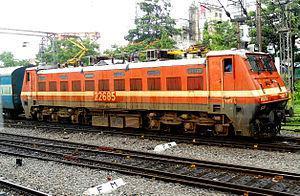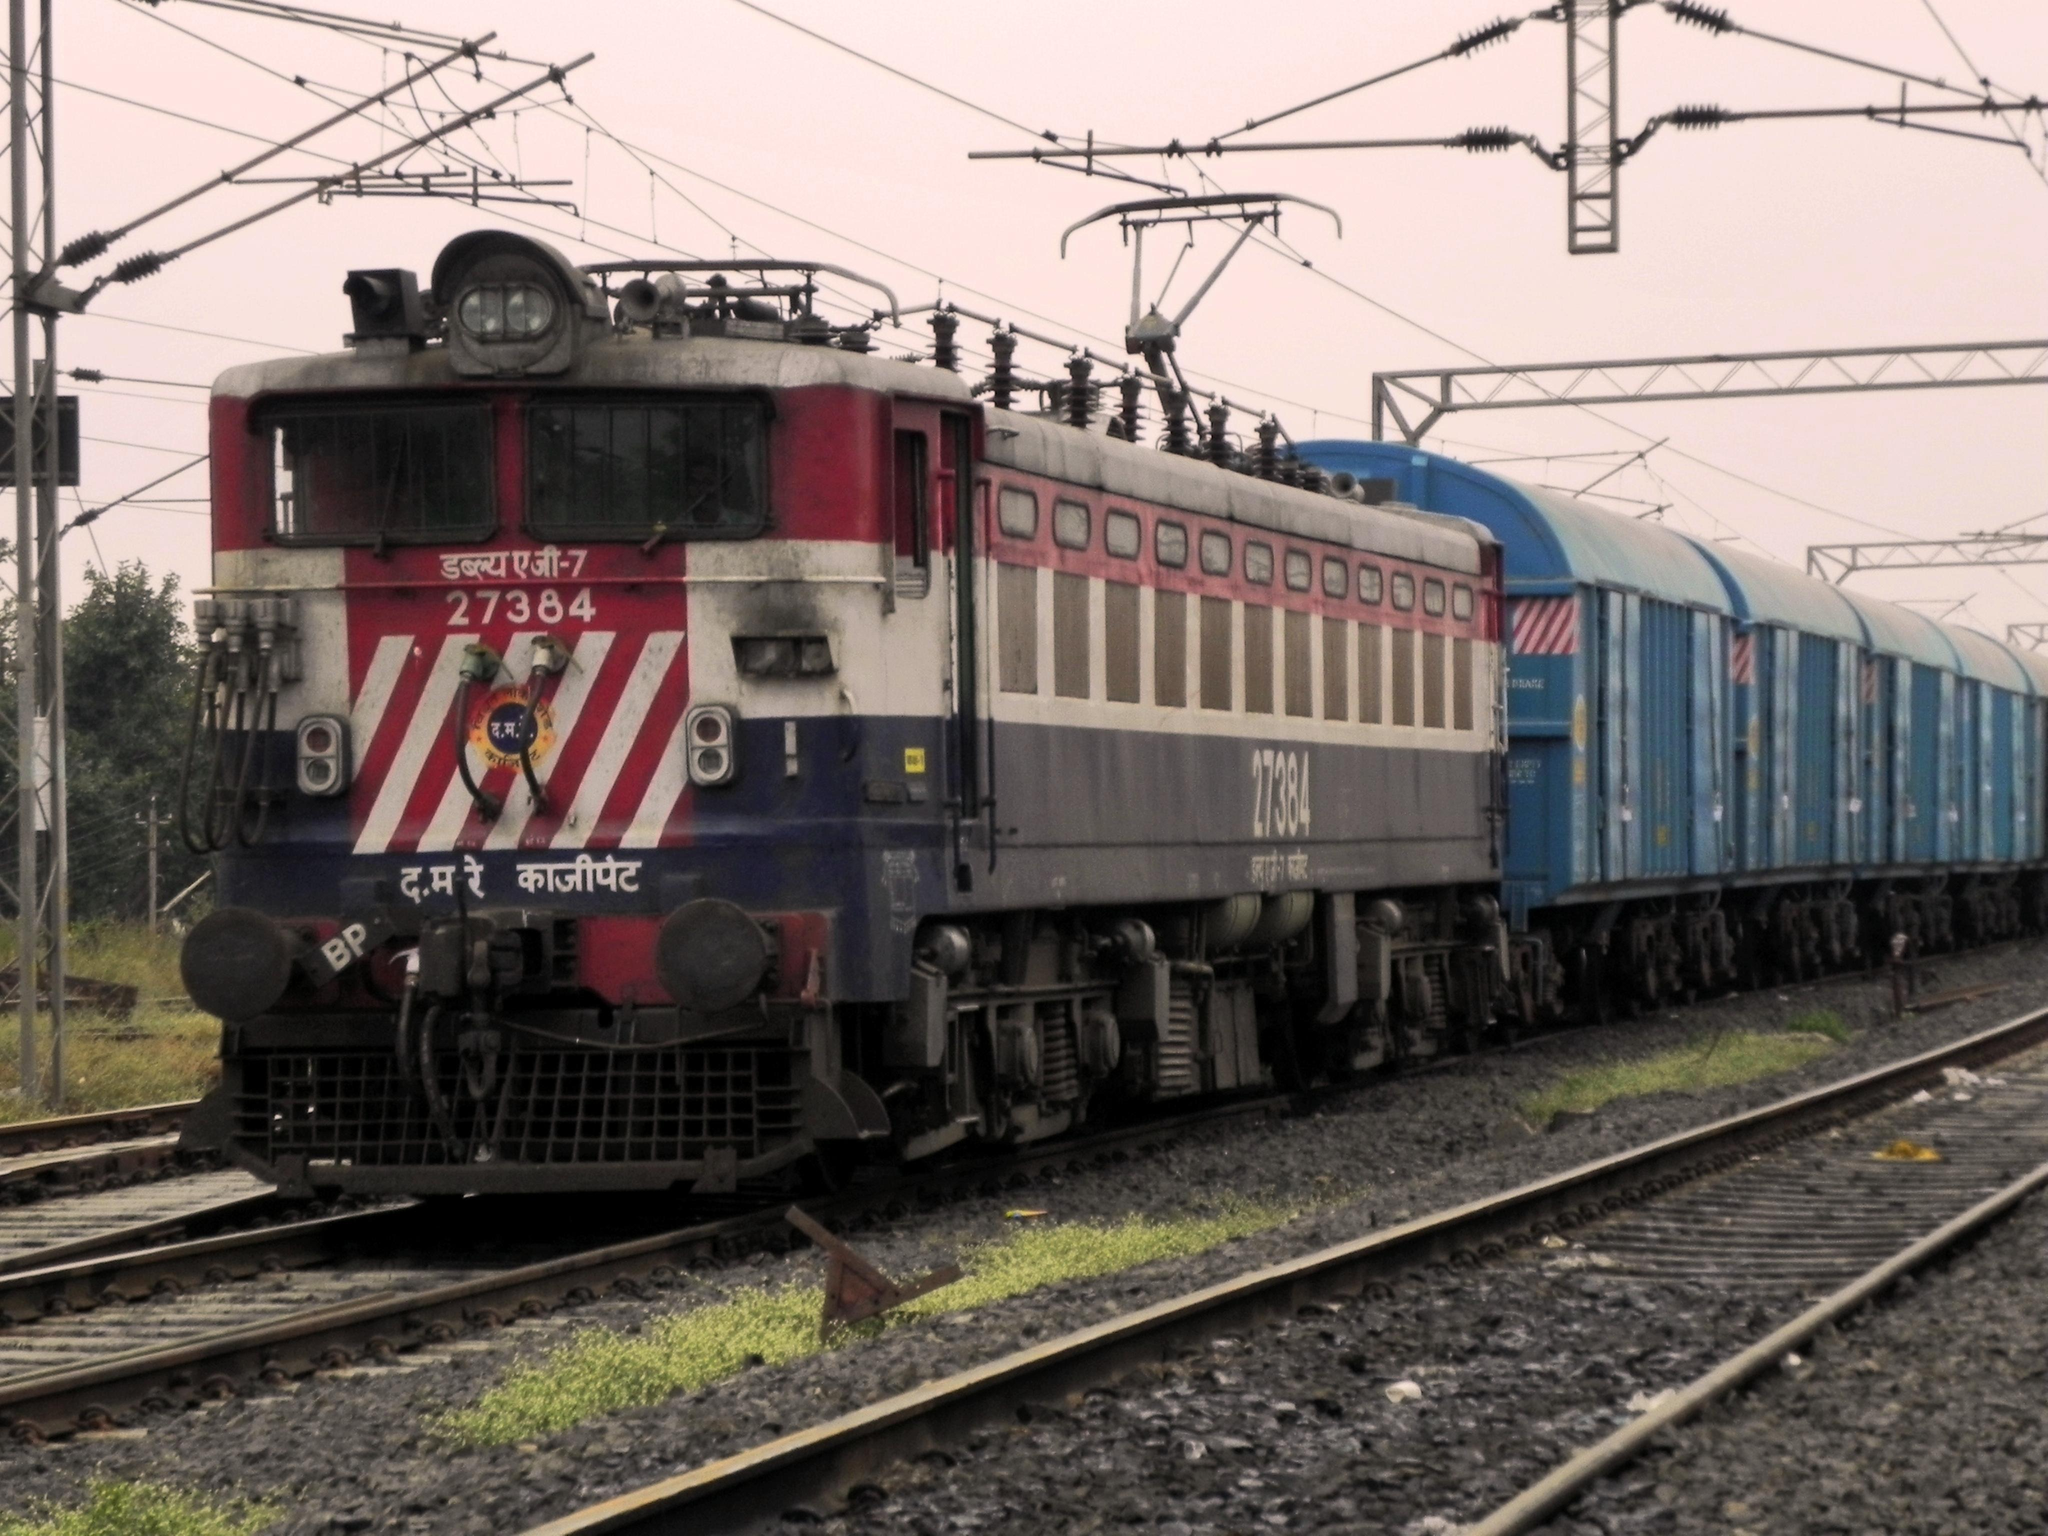The first image is the image on the left, the second image is the image on the right. Considering the images on both sides, is "There are two trains in the image on the right." valid? Answer yes or no. No. 